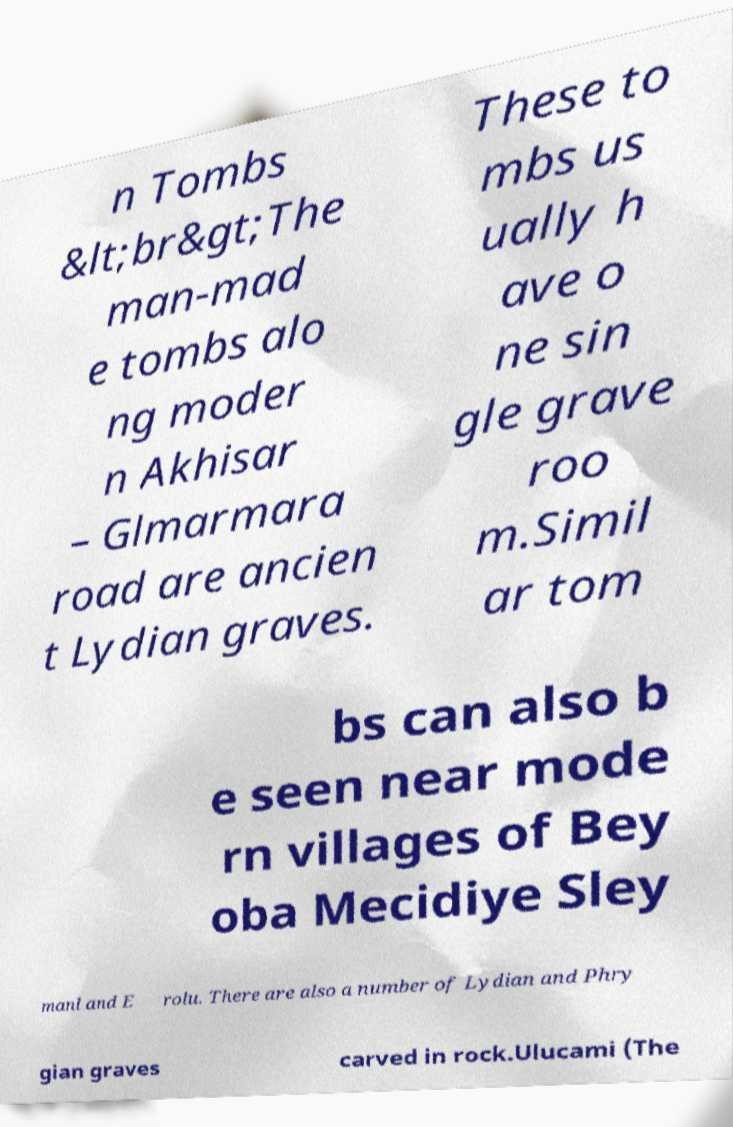Can you accurately transcribe the text from the provided image for me? n Tombs &lt;br&gt;The man-mad e tombs alo ng moder n Akhisar – Glmarmara road are ancien t Lydian graves. These to mbs us ually h ave o ne sin gle grave roo m.Simil ar tom bs can also b e seen near mode rn villages of Bey oba Mecidiye Sley manl and E rolu. There are also a number of Lydian and Phry gian graves carved in rock.Ulucami (The 